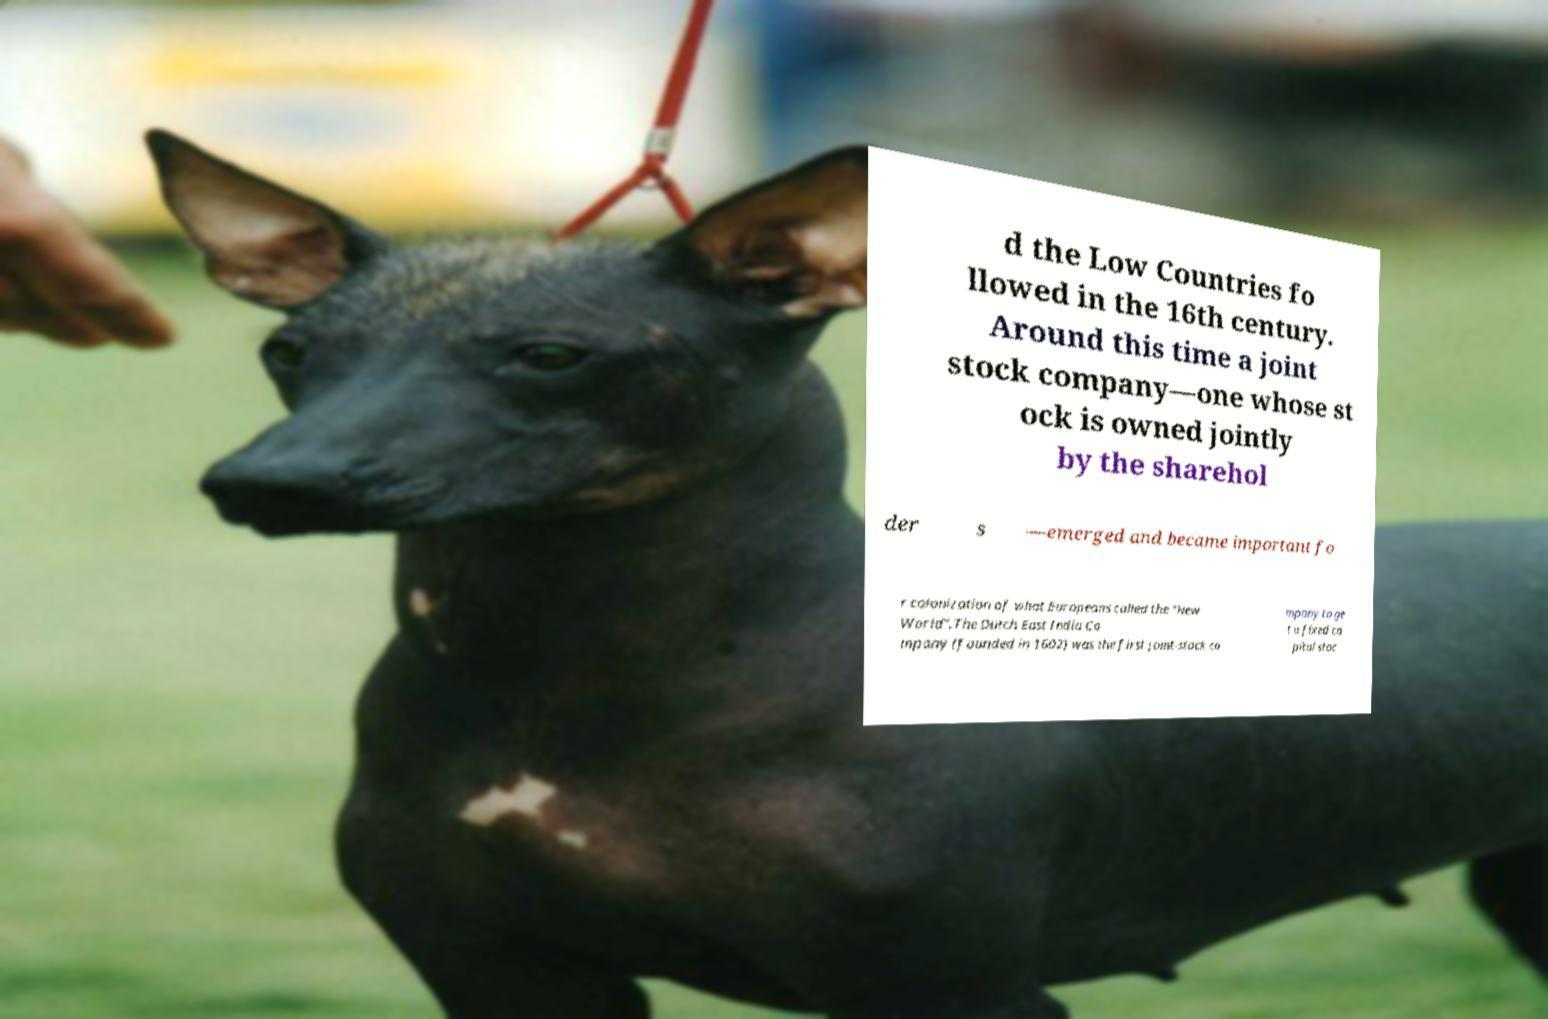What messages or text are displayed in this image? I need them in a readable, typed format. d the Low Countries fo llowed in the 16th century. Around this time a joint stock company—one whose st ock is owned jointly by the sharehol der s —emerged and became important fo r colonization of what Europeans called the "New World".The Dutch East India Co mpany (founded in 1602) was the first joint-stock co mpany to ge t a fixed ca pital stoc 